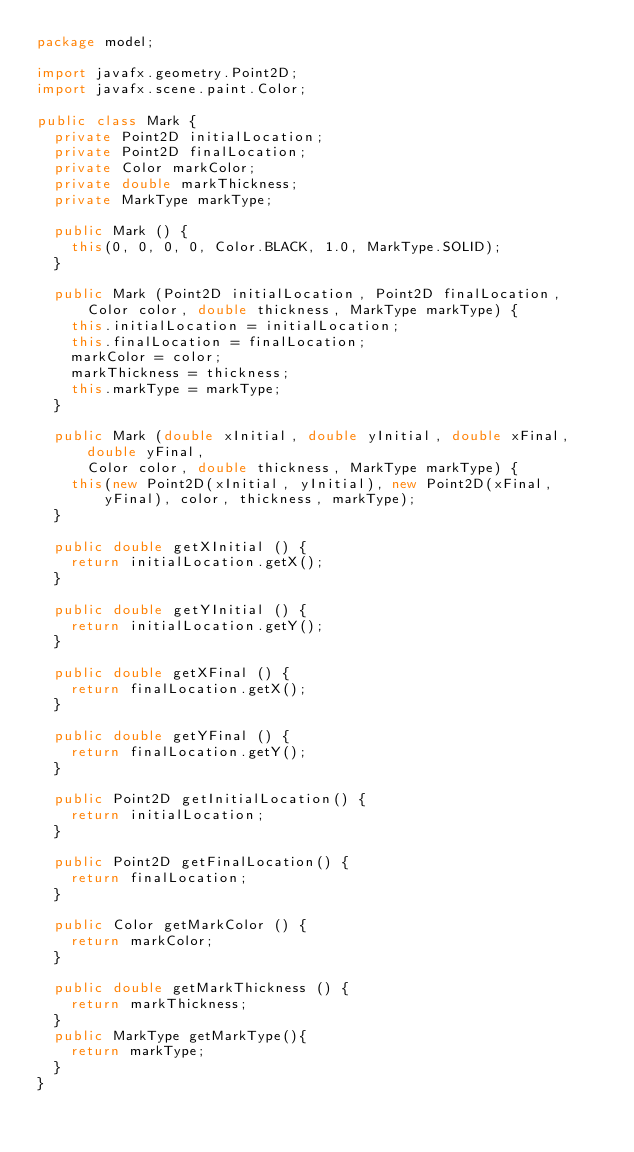Convert code to text. <code><loc_0><loc_0><loc_500><loc_500><_Java_>package model;

import javafx.geometry.Point2D;
import javafx.scene.paint.Color;

public class Mark {
	private Point2D initialLocation;
	private Point2D finalLocation;
	private Color markColor;
	private double markThickness;
	private MarkType markType;
	
	public Mark () {
		this(0, 0, 0, 0, Color.BLACK, 1.0, MarkType.SOLID);
	}
	
	public Mark (Point2D initialLocation, Point2D finalLocation, 
			Color color, double thickness, MarkType markType) {
		this.initialLocation = initialLocation;
		this.finalLocation = finalLocation;
		markColor = color;
		markThickness = thickness;
		this.markType = markType;
	}
	
	public Mark (double xInitial, double yInitial, double xFinal, double yFinal, 
			Color color, double thickness, MarkType markType) {
		this(new Point2D(xInitial, yInitial), new Point2D(xFinal, yFinal), color, thickness, markType);
	}
	
	public double getXInitial () {
		return initialLocation.getX();
	}

	public double getYInitial () {
		return initialLocation.getY();
	}
	
	public double getXFinal () {
		return finalLocation.getX();
	}
	
	public double getYFinal () {
		return finalLocation.getY();
	}
	
	public Point2D getInitialLocation() {
		return initialLocation;
	}
	
	public Point2D getFinalLocation() {
		return finalLocation;
	}
	
	public Color getMarkColor () {
		return markColor;
	}
	
	public double getMarkThickness () {
		return markThickness;
	}
	public MarkType getMarkType(){
		return markType;
	}
}
</code> 